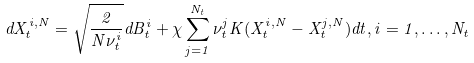<formula> <loc_0><loc_0><loc_500><loc_500>d X ^ { i , N } _ { t } = \sqrt { \frac { 2 } { N \nu ^ { i } _ { t } } } d B ^ { i } _ { t } + \chi \sum _ { j = 1 } ^ { N _ { t } } \nu ^ { j } _ { t } K ( X ^ { i , N } _ { t } - X ^ { j , N } _ { t } ) d t , i = 1 , \dots , N _ { t }</formula> 